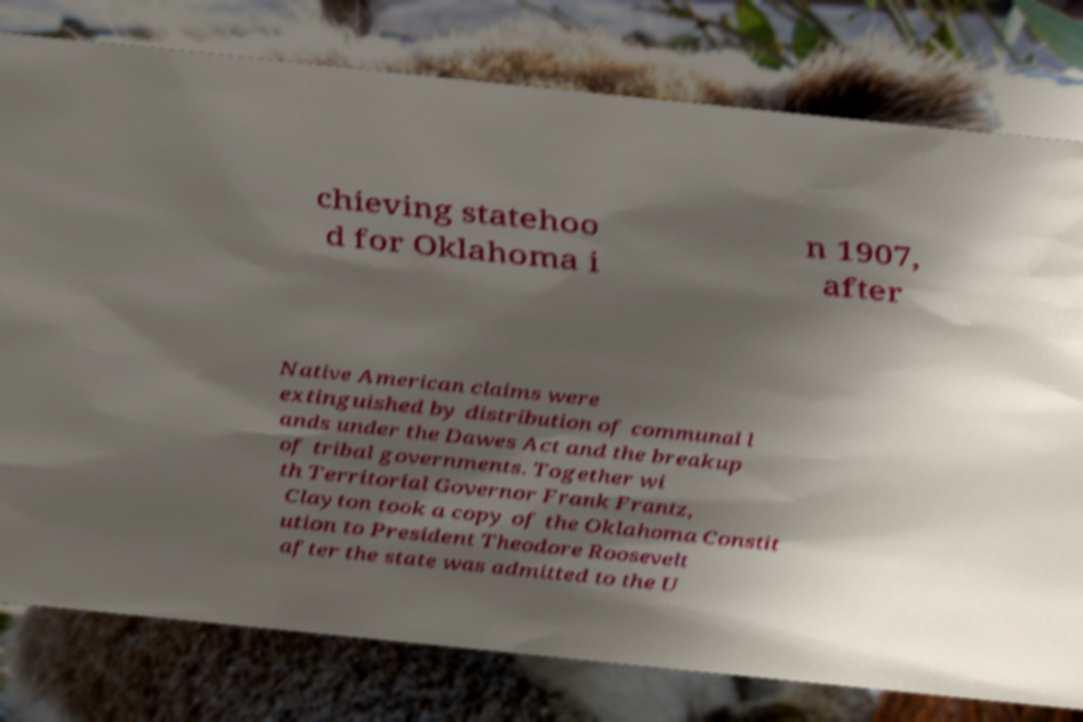Could you extract and type out the text from this image? chieving statehoo d for Oklahoma i n 1907, after Native American claims were extinguished by distribution of communal l ands under the Dawes Act and the breakup of tribal governments. Together wi th Territorial Governor Frank Frantz, Clayton took a copy of the Oklahoma Constit ution to President Theodore Roosevelt after the state was admitted to the U 